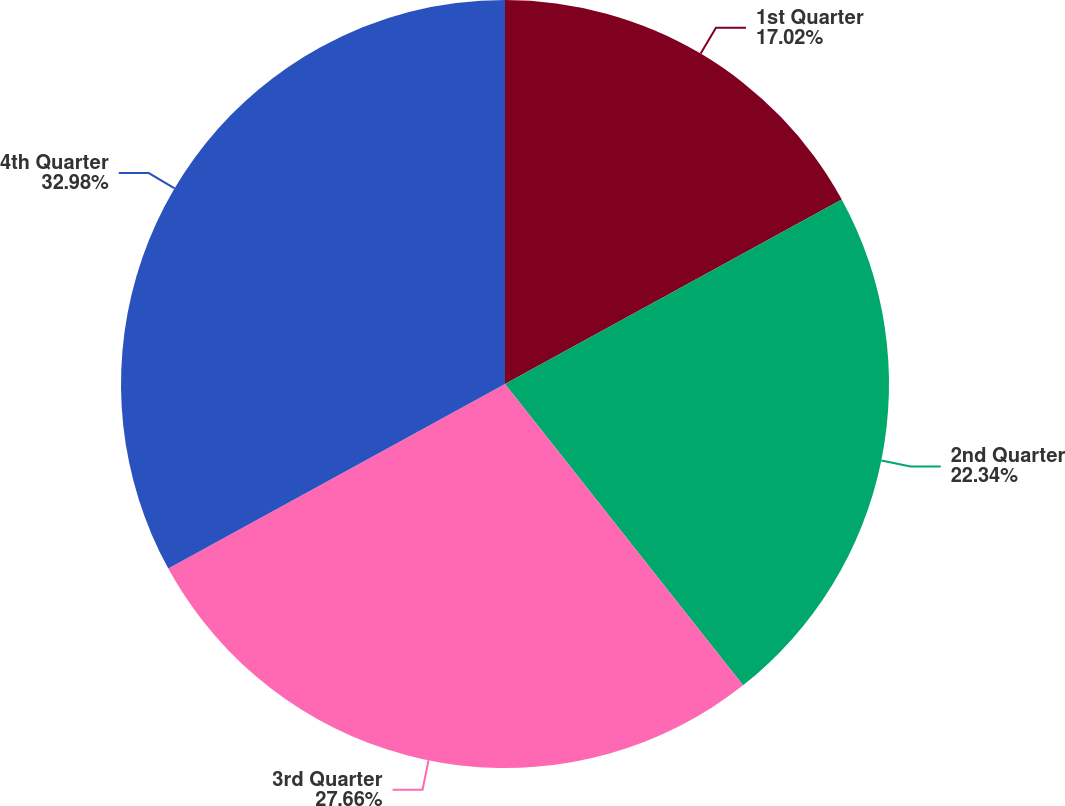<chart> <loc_0><loc_0><loc_500><loc_500><pie_chart><fcel>1st Quarter<fcel>2nd Quarter<fcel>3rd Quarter<fcel>4th Quarter<nl><fcel>17.02%<fcel>22.34%<fcel>27.66%<fcel>32.98%<nl></chart> 